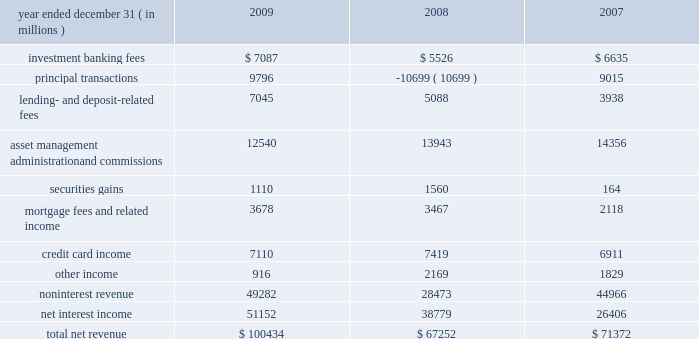Jpmorgan chase & co./2009 annual report consolidated results of operations this following section provides a comparative discussion of jpmorgan chase 2019s consolidated results of operations on a reported basis for the three-year period ended december 31 , 2009 .
Factors that related primarily to a single business segment are discussed in more detail within that business segment .
For a discussion of the critical ac- counting estimates used by the firm that affect the consolidated results of operations , see pages 135 2013139 of this annual report .
Revenue year ended december 31 , ( in millions ) 2009 2008 2007 .
2009 compared with 2008 total net revenue was $ 100.4 billion , up by $ 33.2 billion , or 49% ( 49 % ) , from the prior year .
The increase was driven by higher principal transactions revenue , primarily related to improved performance across most fixed income and equity products , and the absence of net markdowns on legacy leveraged lending and mortgage positions in ib , as well as higher levels of trading gains and investment securities income in corporate/private equity .
Results also benefited from the impact of the washington mutual transaction , which contributed to increases in net interest income , lending- and deposit-related fees , and mortgage fees and related income .
Lastly , higher investment banking fees also contributed to revenue growth .
These increases in revenue were offset partially by reduced fees and commissions from the effect of lower market levels on assets under management and custody , and the absence of proceeds from the sale of visa shares in its initial public offering in the first quarter of 2008 .
Investment banking fees increased from the prior year , due to higher equity and debt underwriting fees .
For a further discussion of invest- ment banking fees , which are primarily recorded in ib , see ib segment results on pages 63 201365 of this annual report .
Principal transactions revenue , which consists of revenue from trading and private equity investing activities , was significantly higher com- pared with the prior year .
Trading revenue increased , driven by improved performance across most fixed income and equity products ; modest net gains on legacy leveraged lending and mortgage-related positions , compared with net markdowns of $ 10.6 billion in the prior year ; and gains on trading positions in corporate/private equity , compared with losses in the prior year of $ 1.1 billion on markdowns of federal national mortgage association ( 201cfannie mae 201d ) and fed- eral home loan mortgage corporation ( 201cfreddie mac 201d ) preferred securities .
These increases in revenue were offset partially by an aggregate loss of $ 2.3 billion from the tightening of the firm 2019s credit spread on certain structured liabilities and derivatives , compared with gains of $ 2.0 billion in the prior year from widening spreads on these liabilities and derivatives .
The firm 2019s private equity investments pro- duced a slight net loss in 2009 , a significant improvement from a larger net loss in 2008 .
For a further discussion of principal transac- tions revenue , see ib and corporate/private equity segment results on pages 63 201365 and 82 201383 , respectively , and note 3 on pages 156 2013 173 of this annual report .
Lending- and deposit-related fees rose from the prior year , predomi- nantly reflecting the impact of the washington mutual transaction and organic growth in both lending- and deposit-related fees in rfs , cb , ib and tss .
For a further discussion of lending- and deposit- related fees , which are mostly recorded in rfs , tss and cb , see the rfs segment results on pages 66 201371 , the tss segment results on pages 77 201378 , and the cb segment results on pages 75 201376 of this annual report .
The decline in asset management , administration and commissions revenue compared with the prior year was largely due to lower asset management fees in am from the effect of lower market levels .
Also contributing to the decrease were lower administration fees in tss , driven by the effect of market depreciation on certain custody assets and lower securities lending balances ; and lower brokerage commis- sions revenue in ib , predominantly related to lower transaction vol- ume .
For additional information on these fees and commissions , see the segment discussions for tss on pages 77 201378 , and am on pages 79 201381 of this annual report .
Securities gains were lower in 2009 and included credit losses related to other-than-temporary impairment and lower gains on the sale of mastercard shares of $ 241 million in 2009 , compared with $ 668 million in 2008 .
These decreases were offset partially by higher gains from repositioning the corporate investment securities portfolio in connection with managing the firm 2019s structural interest rate risk .
For a further discussion of securities gains , which are mostly recorded in corporate/private equity , see the corpo- rate/private equity segment discussion on pages 82 201383 of this annual report .
Mortgage fees and related income increased slightly from the prior year , as higher net mortgage servicing revenue was largely offset by lower production revenue .
The increase in net mortgage servicing revenue was driven by growth in average third-party loans serviced as a result of the washington mutual transaction .
Mortgage production revenue declined from the prior year , reflecting an increase in esti- mated losses from the repurchase of previously-sold loans , offset partially by wider margins on new originations .
For a discussion of mortgage fees and related income , which is recorded primarily in rfs 2019s consumer lending business , see the consumer lending discus- sion on pages 68 201371 of this annual report .
Credit card income , which includes the impact of the washington mutual transaction , decreased slightly compared with the prior year .
What percent of total net revenue was noninterest revenue in 2008? 
Computations: (28473 / 67252)
Answer: 0.42338. 